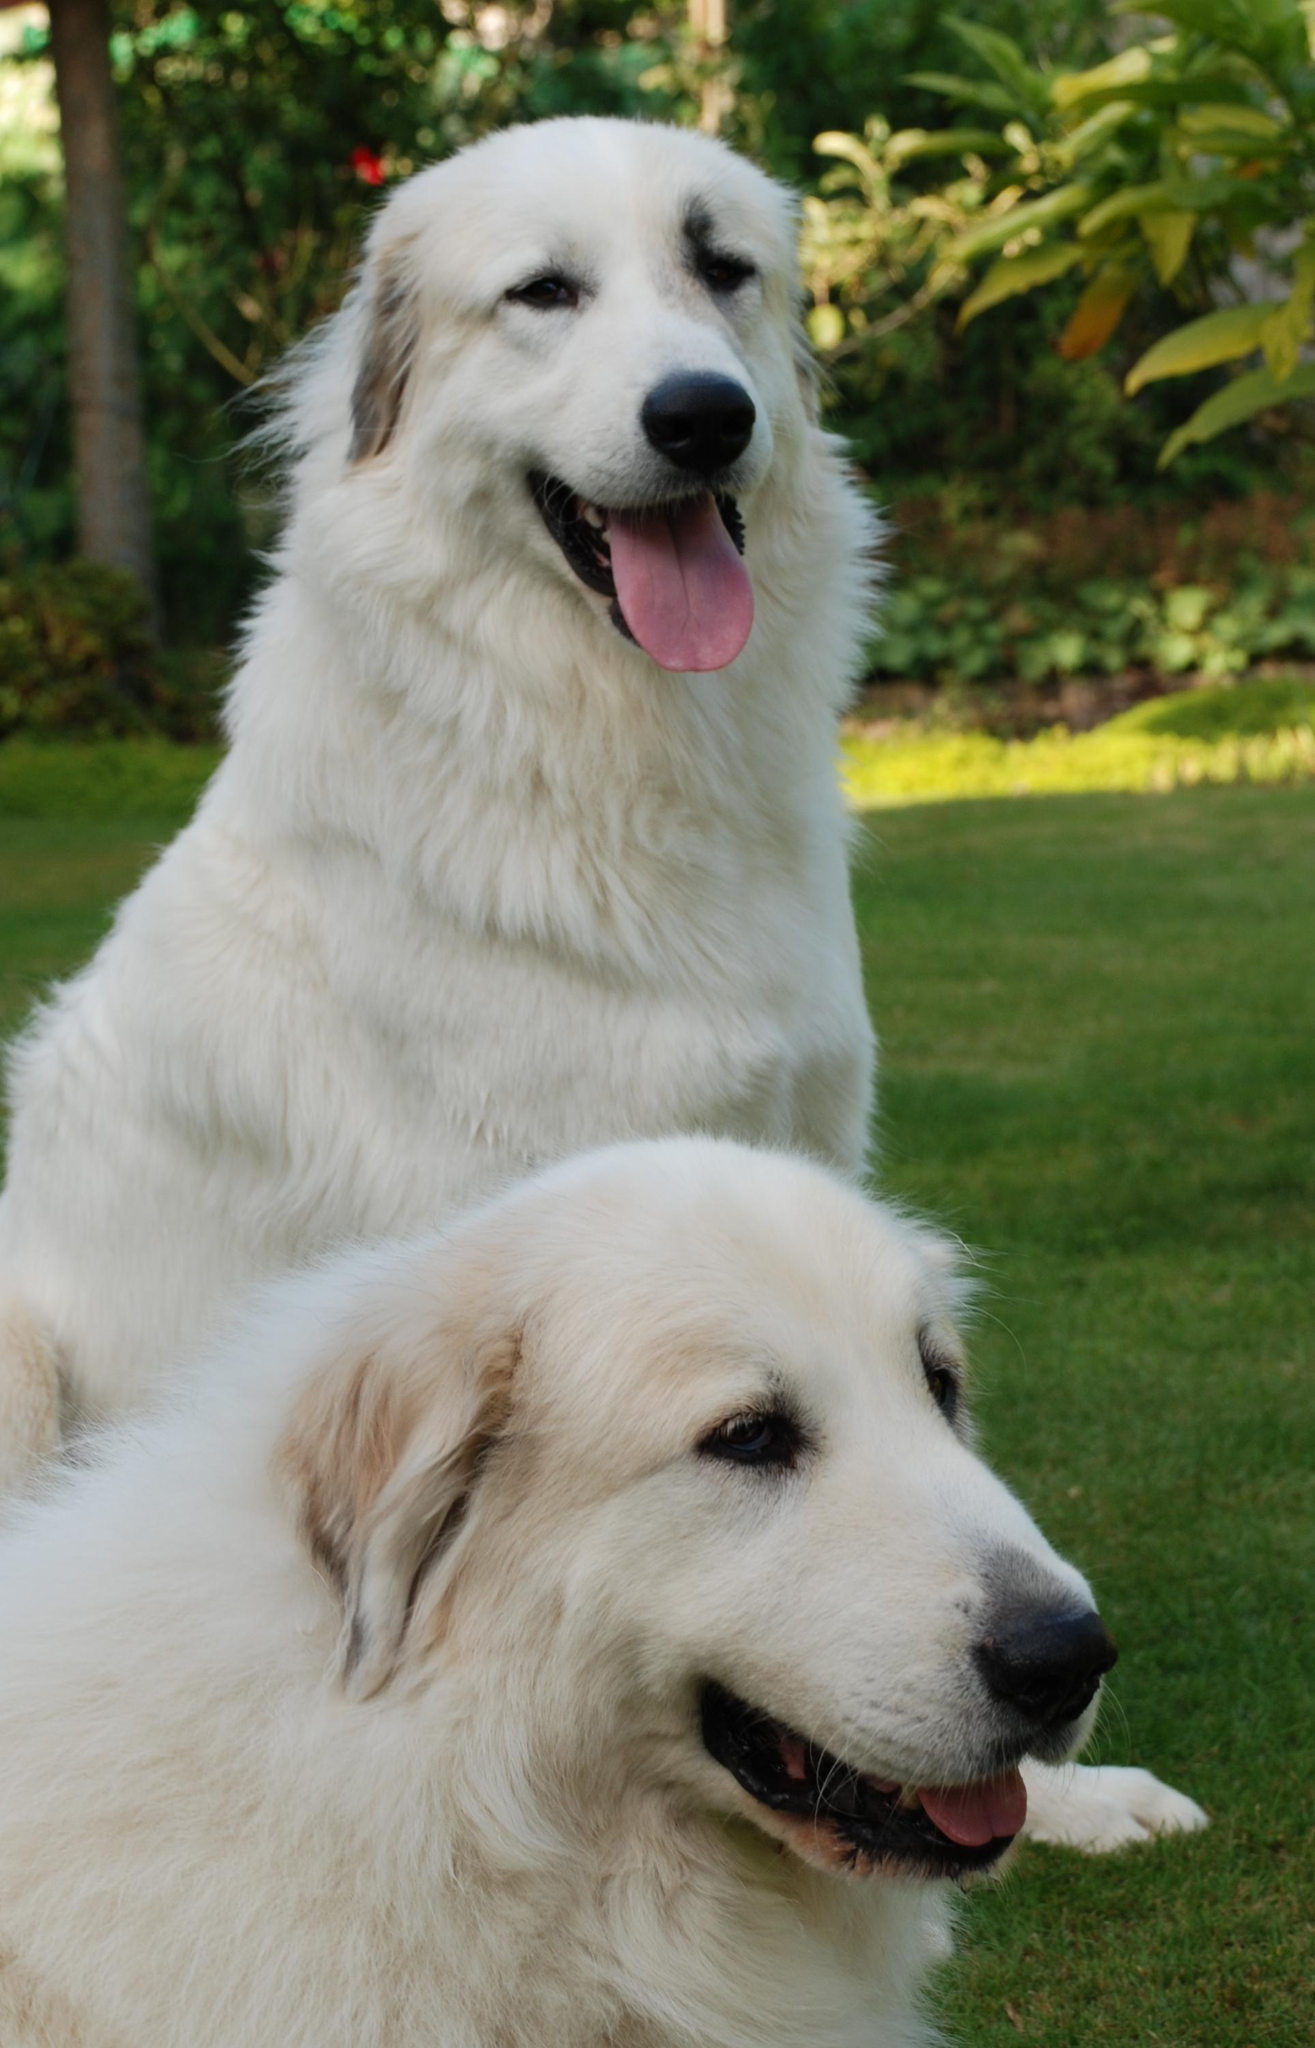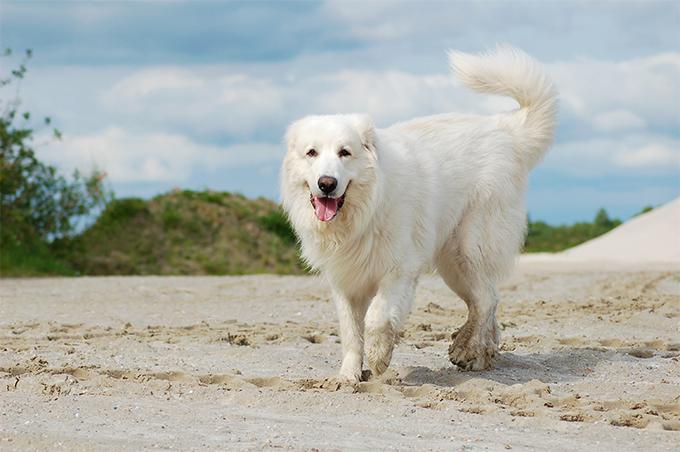The first image is the image on the left, the second image is the image on the right. For the images displayed, is the sentence "At least one of the dogs is with a human." factually correct? Answer yes or no. No. 